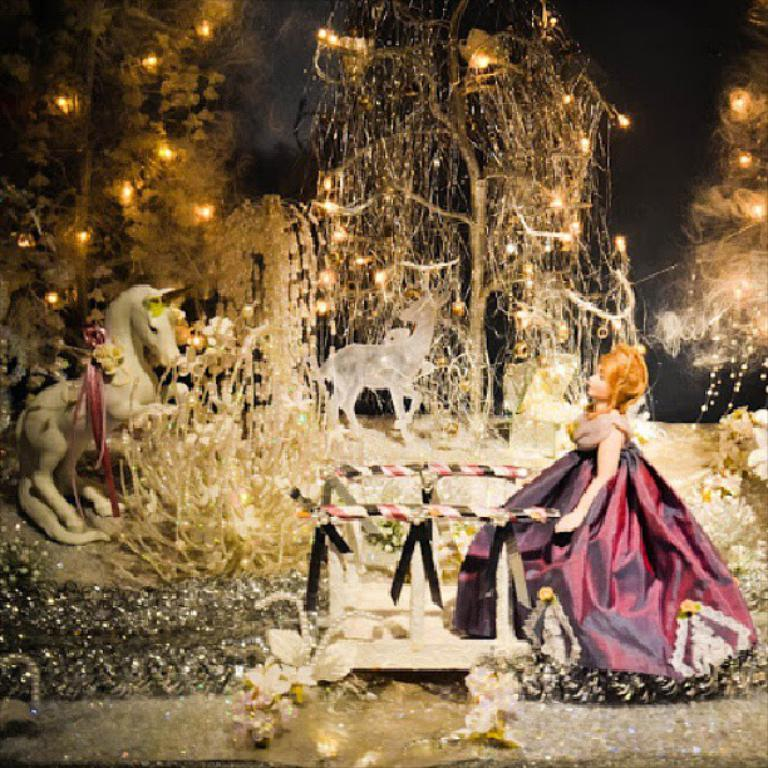What is the main subject of the image? There is a doll in the image. What is the doll wearing? The doll is wearing a maroon dress. What other object is present in the image? There is a white horse in the image. What can be seen in the background of the image? There are trees and lights visible in the background of the image. Can you see any sheep in the image? There are no sheep present in the image. What type of magic is being performed by the doll in the image? There is no magic or any indication of magical activity in the image; it simply features a doll and a white horse. 